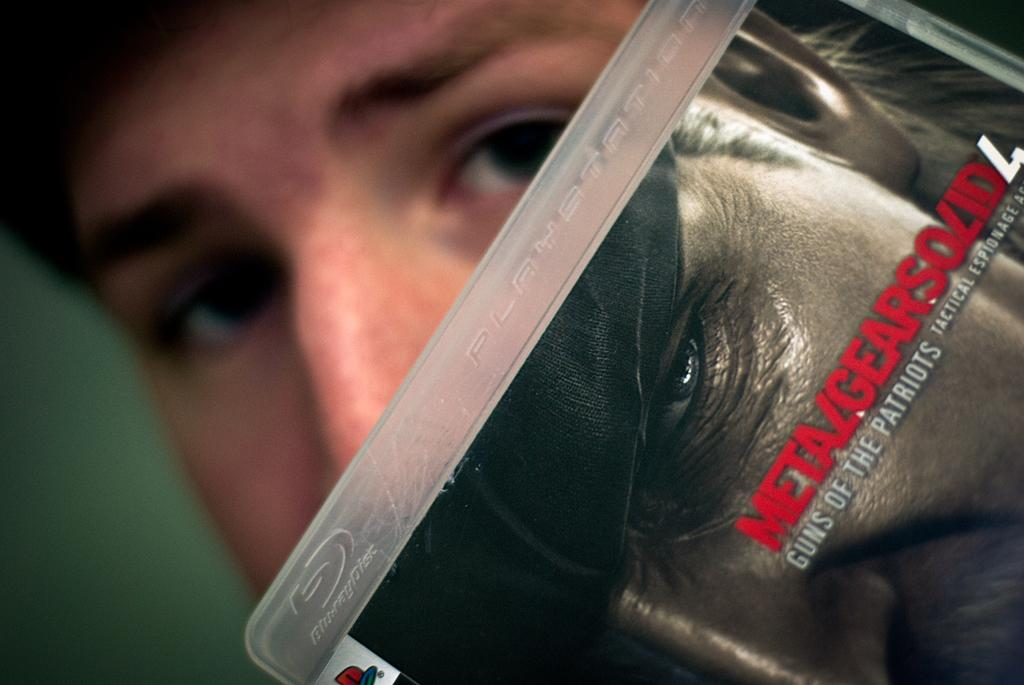What is the main subject of the image? There is a person in the image. What is the person doing in the image? The person is posing. Can you identify any objects in the image? Yes, there is a PlayStation CD in the image. How many centimeters long is the bun in the image? There is no bun present in the image. 